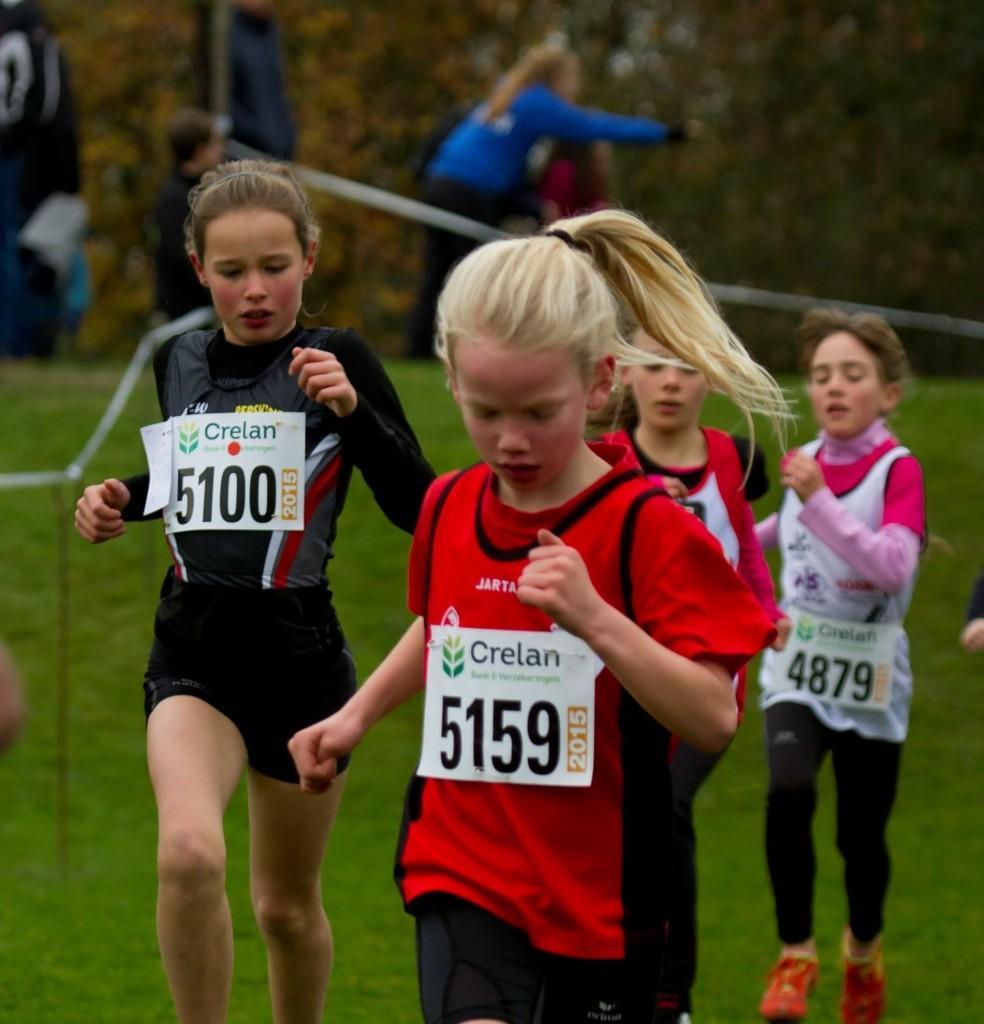In one or two sentences, can you explain what this image depicts? In this picture there are four small girl wearing red and black color t-shirt running in the grass ground. Behind there is a blur background. 